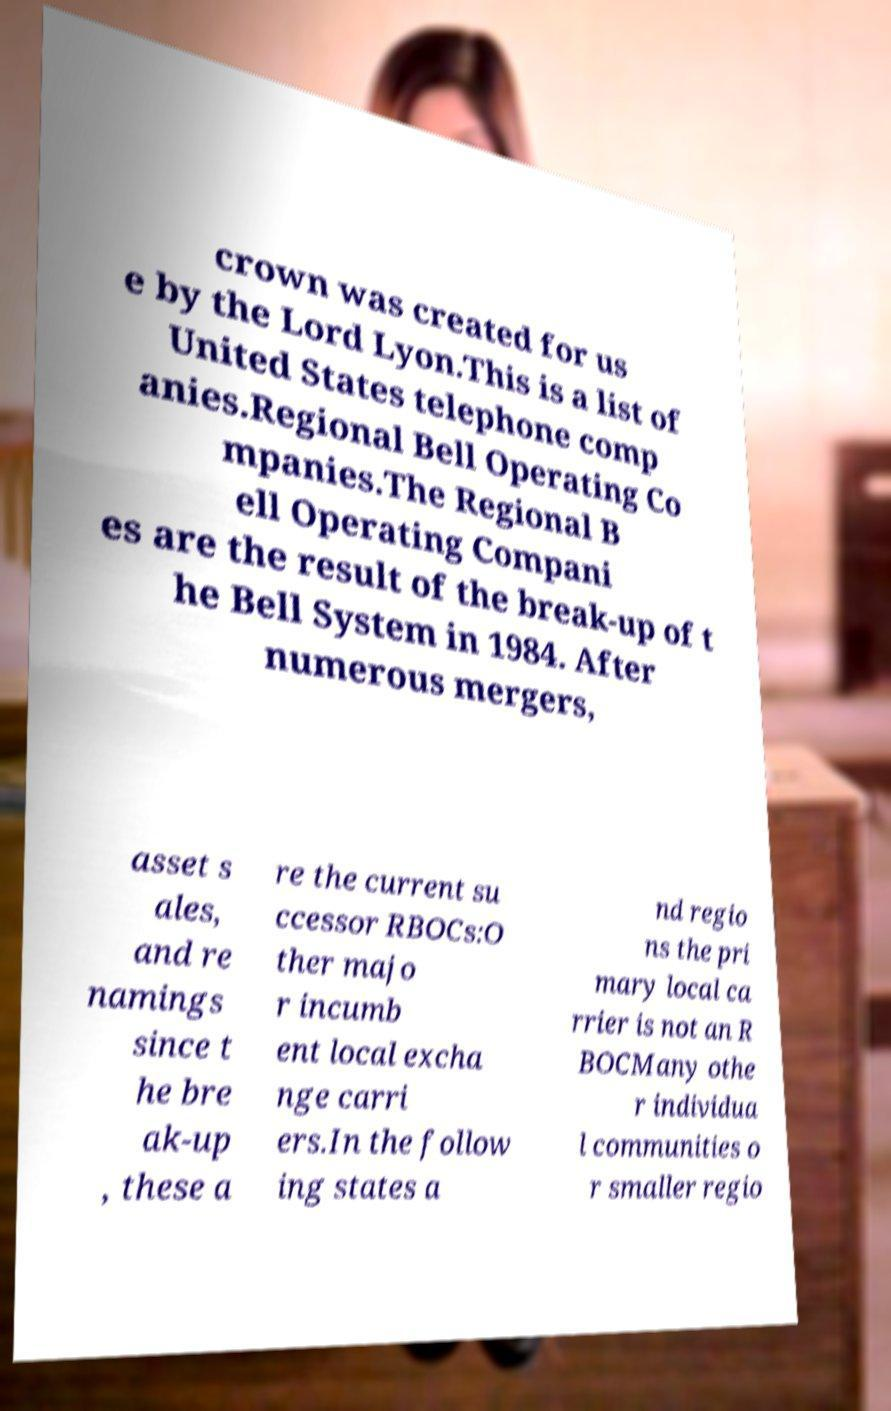What messages or text are displayed in this image? I need them in a readable, typed format. crown was created for us e by the Lord Lyon.This is a list of United States telephone comp anies.Regional Bell Operating Co mpanies.The Regional B ell Operating Compani es are the result of the break-up of t he Bell System in 1984. After numerous mergers, asset s ales, and re namings since t he bre ak-up , these a re the current su ccessor RBOCs:O ther majo r incumb ent local excha nge carri ers.In the follow ing states a nd regio ns the pri mary local ca rrier is not an R BOCMany othe r individua l communities o r smaller regio 